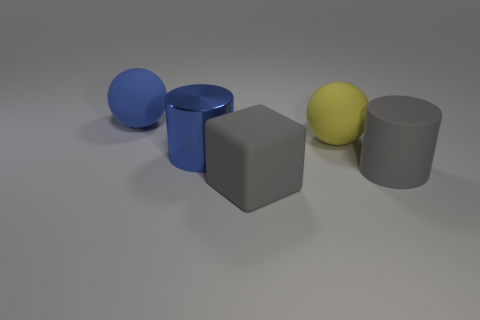Add 2 big blue shiny cylinders. How many objects exist? 7 Subtract all blue spheres. How many spheres are left? 1 Subtract 1 cubes. How many cubes are left? 0 Subtract all cubes. How many objects are left? 4 Subtract all green spheres. How many red cylinders are left? 0 Subtract all matte balls. Subtract all large purple metallic blocks. How many objects are left? 3 Add 2 big gray cylinders. How many big gray cylinders are left? 3 Add 4 big gray rubber objects. How many big gray rubber objects exist? 6 Subtract 0 green balls. How many objects are left? 5 Subtract all green blocks. Subtract all brown balls. How many blocks are left? 1 